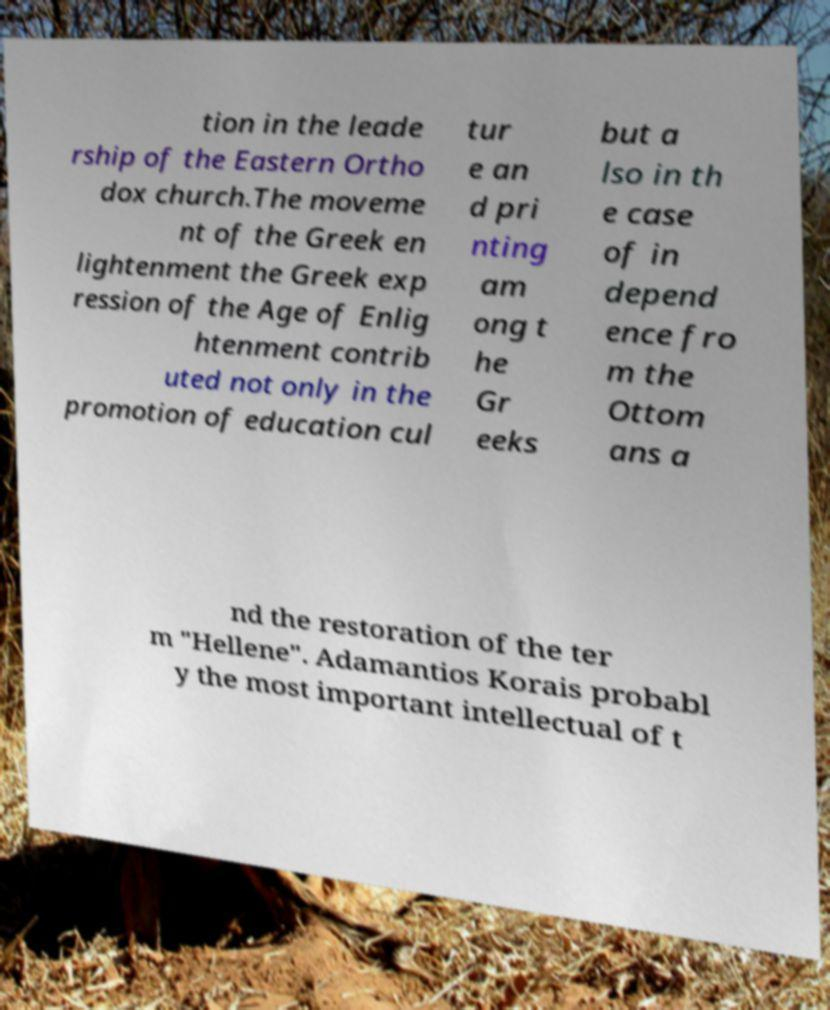Could you assist in decoding the text presented in this image and type it out clearly? tion in the leade rship of the Eastern Ortho dox church.The moveme nt of the Greek en lightenment the Greek exp ression of the Age of Enlig htenment contrib uted not only in the promotion of education cul tur e an d pri nting am ong t he Gr eeks but a lso in th e case of in depend ence fro m the Ottom ans a nd the restoration of the ter m "Hellene". Adamantios Korais probabl y the most important intellectual of t 